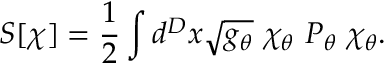Convert formula to latex. <formula><loc_0><loc_0><loc_500><loc_500>S [ \chi ] = { \frac { 1 } { 2 } } \int d ^ { D } x \sqrt { g _ { \theta } } \ \chi _ { \theta } \ P _ { \theta } \ \chi _ { \theta } .</formula> 